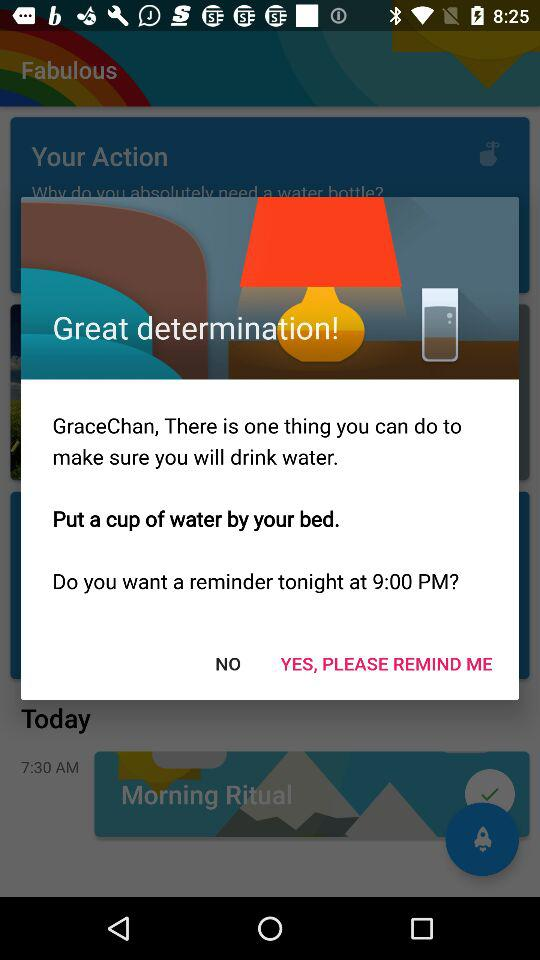What's the reminder time for tonight? The reminder time for tonight is 9:00 PM. 